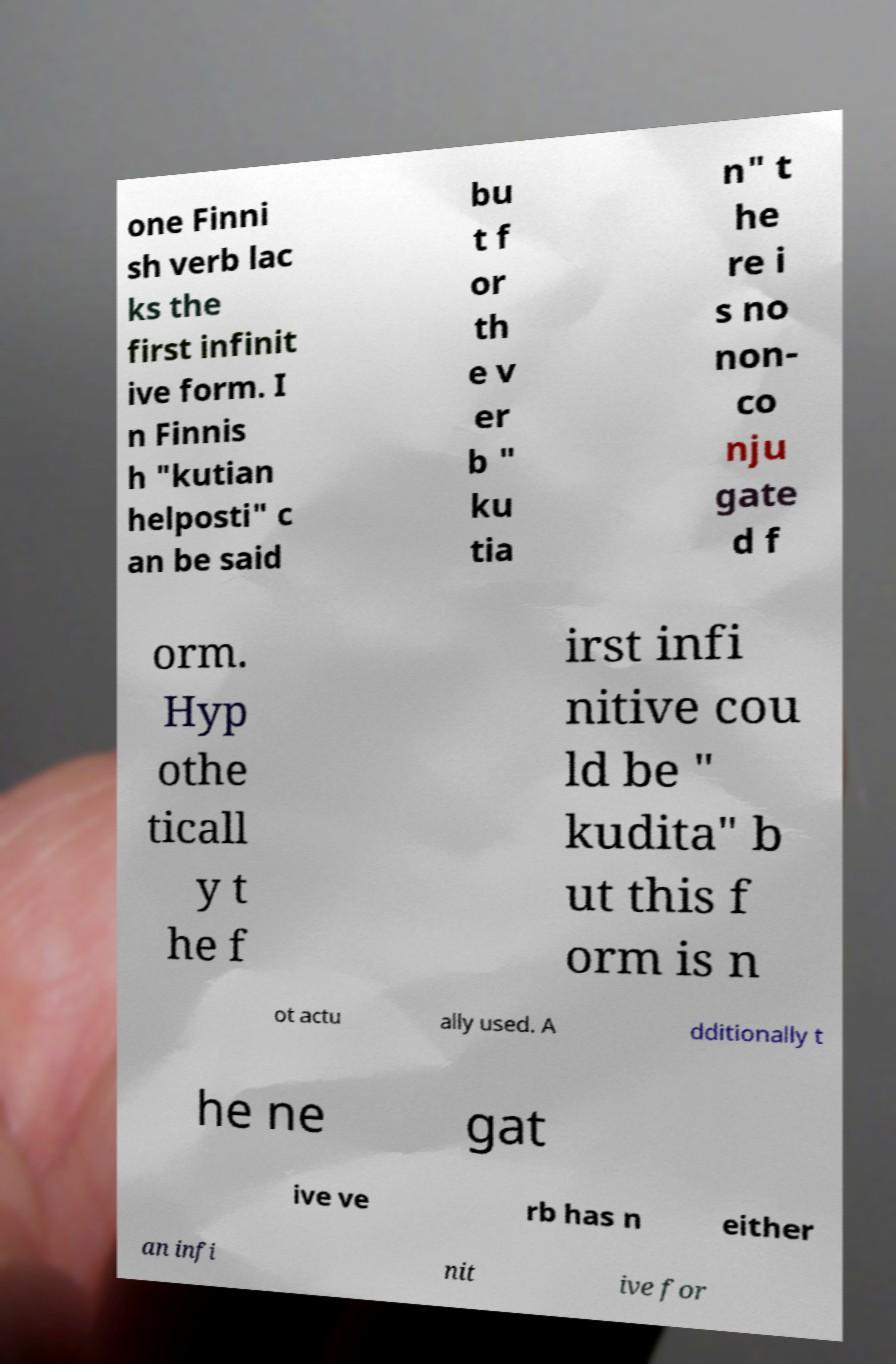Can you read and provide the text displayed in the image?This photo seems to have some interesting text. Can you extract and type it out for me? one Finni sh verb lac ks the first infinit ive form. I n Finnis h "kutian helposti" c an be said bu t f or th e v er b " ku tia n" t he re i s no non- co nju gate d f orm. Hyp othe ticall y t he f irst infi nitive cou ld be " kudita" b ut this f orm is n ot actu ally used. A dditionally t he ne gat ive ve rb has n either an infi nit ive for 